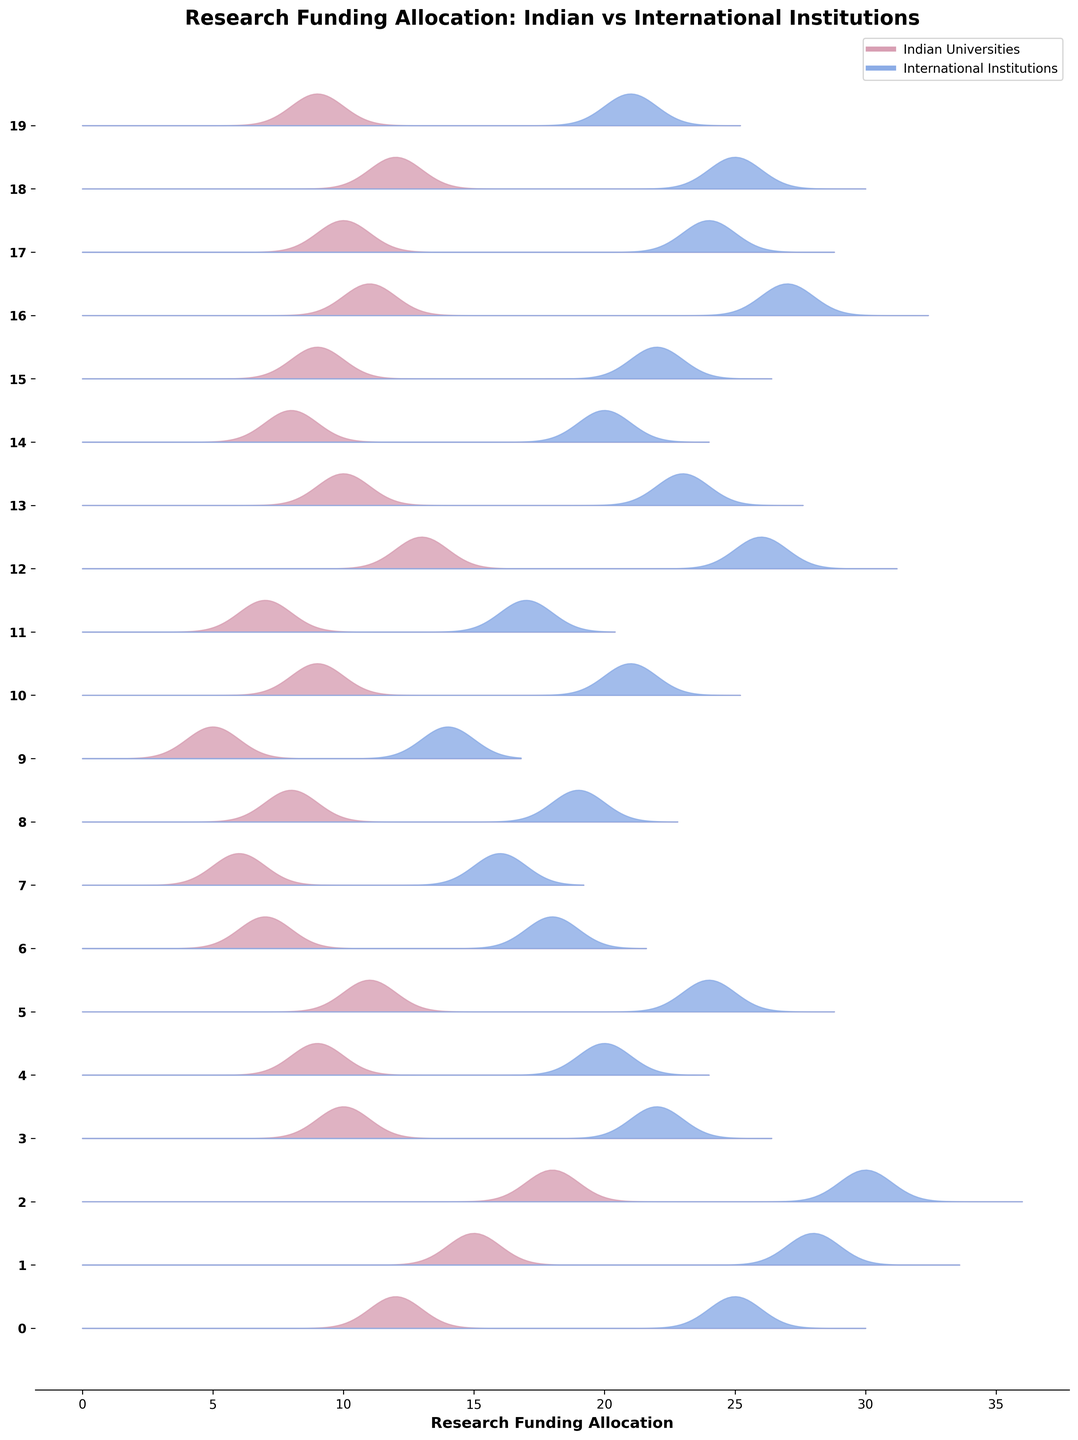What is the title of the figure? The title of a figure in a plot is typically placed at the top and gives a summary of what the figure represents. By looking at the figure, you'll see the title written there.
Answer: "Research Funding Allocation: Indian vs International Institutions" How many fields of study are compared in the figure? Observing the number of distinct labels on the y-axis gives the total number of fields of study being compared. The number of data points (fields of study) is equal to the number of distinct y-tick labels.
Answer: 20 Which field receives the highest research funding in Indian universities? By observing the ridgelines for Indian Universities, the height of the peak indicates the level of funding. Identify the field with the highest peak.
Answer: Medicine Which field of study has the greatest difference in funding between Indian and international institutions? Compare the gaps between the peaks of each field for Indian and international institutions. The largest vertical distance between the two ridgelines will indicate the greatest difference in funding.
Answer: Artificial Intelligence Which institution allocates more funding to Physics, Indian Universities, or International Institutions? Locate the Physics field along the y-axis, and compare the height of the peaks for Indian Universities and International Institutions. The taller peak will indicate which institution allocates more funding.
Answer: International Institutions What is the average research funding allocated to Chemistry in Indian Universities and International Institutions? For average funding, sum the two amounts (Indian and International), then divide by 2. For Chemistry, add 9 and 20, then divide by 2.
Answer: (9 + 20) / 2 = 14.5 Which field has similar funding allocation between Indian and International institutions? Identify fields where the peaks of both Indian and International ridgelines are close or overlapping. This fields has similar funding.
Answer: Mathematics What is the overall trend in funding allocation for Computer Science when comparing Indian and International Institutions? Examine the relative heights and patterns of the peaks for Computer Science in both types of institutions. Compare Indian funding level with international funding level.
Answer: International Institutions allocate more funding Are there any fields where Indian Universities receive more funding than International Institutions? Identify any fields where the peak for Indian Universities is noticeably higher than for International Institutions.
Answer: No In which fields do International Institutions allocate twice or more funding compared to Indian Universities? Look for fields where the height of the peak for International Institutions is at least twice that of the Indian Universities' peak. Compare fields systematically.
Answer: Psychology, Economics 